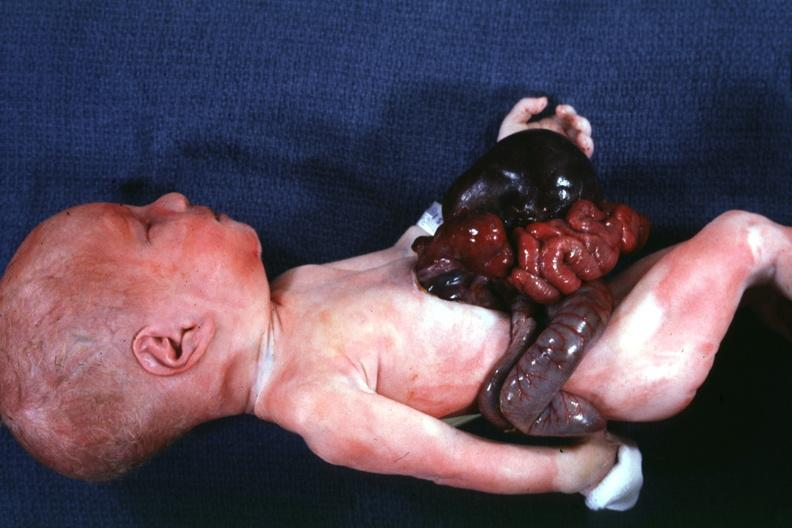what does this image show?
Answer the question using a single word or phrase. A whole body photo 